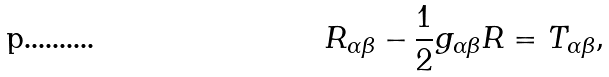Convert formula to latex. <formula><loc_0><loc_0><loc_500><loc_500>R _ { \alpha \beta } - \frac { 1 } { 2 } g _ { \alpha \beta } R = T _ { \alpha \beta } ,</formula> 